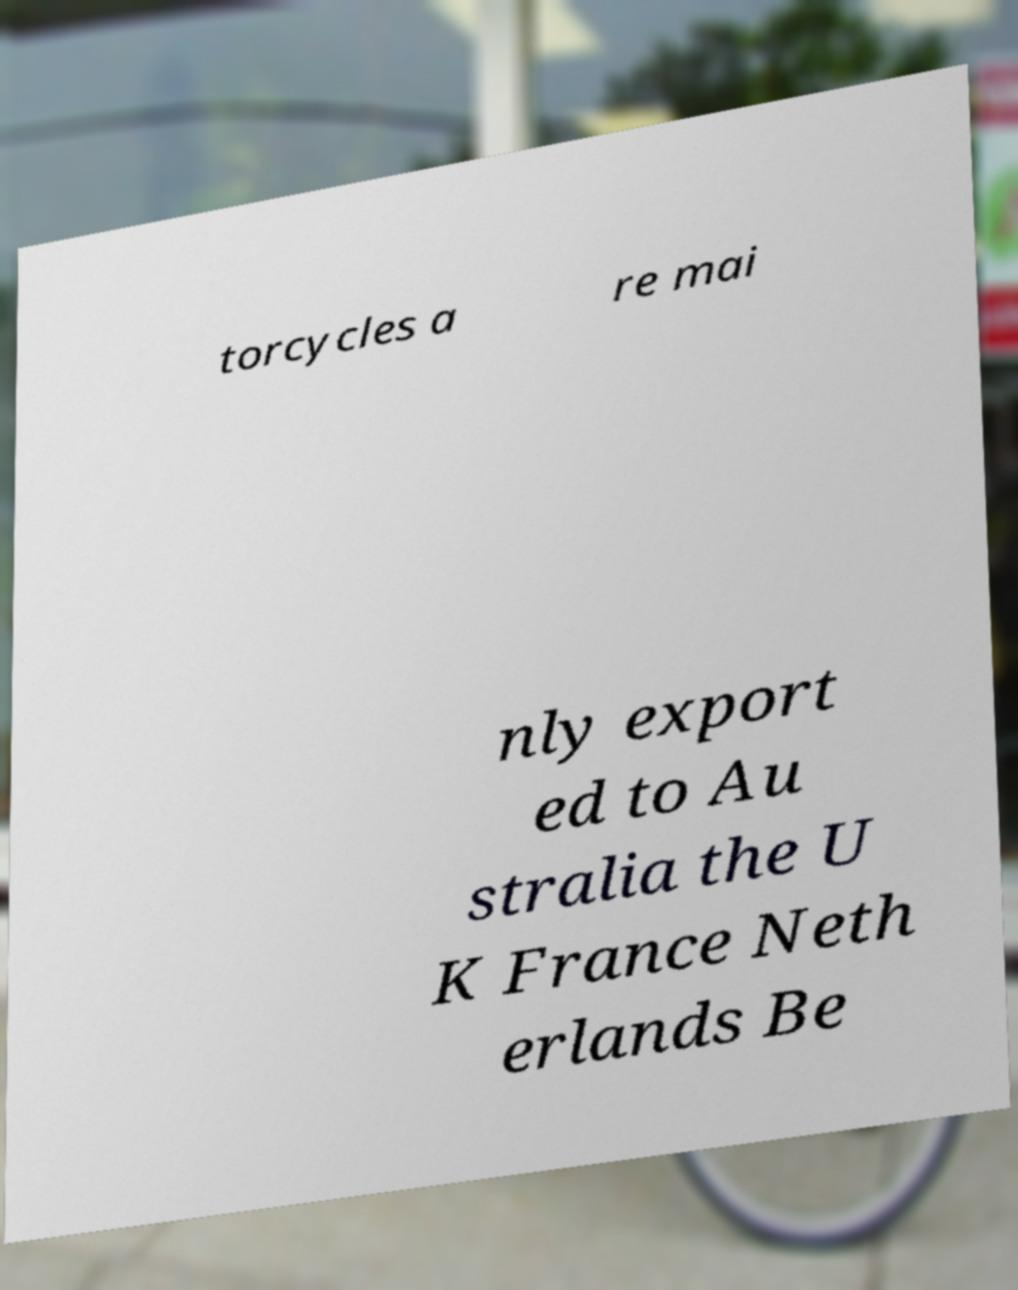For documentation purposes, I need the text within this image transcribed. Could you provide that? torcycles a re mai nly export ed to Au stralia the U K France Neth erlands Be 